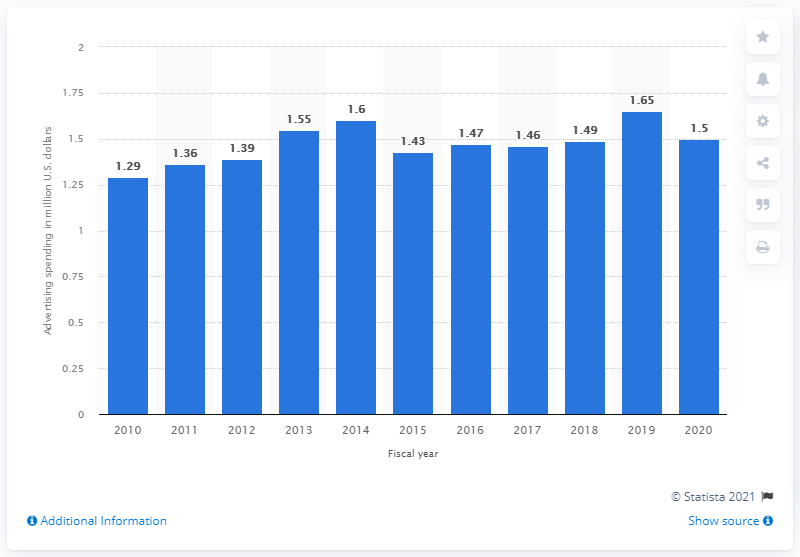Highlight a few significant elements in this photo. The amount of money that Target spent on advertising in a year earlier was significantly higher, at 1.5 times the amount spent in the current year. Target's advertising spending from a year earlier was approximately 1.6... 